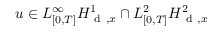Convert formula to latex. <formula><loc_0><loc_0><loc_500><loc_500>u \in L _ { [ 0 , T ] } ^ { \infty } H _ { d , x } ^ { 1 } \cap L _ { [ 0 , T ] } ^ { 2 } H _ { d , x } ^ { 2 }</formula> 